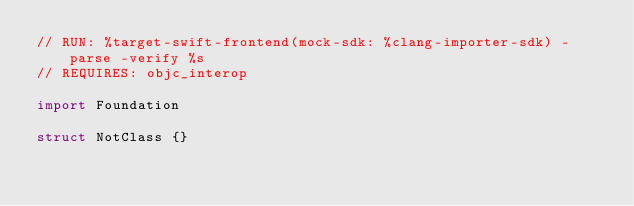<code> <loc_0><loc_0><loc_500><loc_500><_Swift_>// RUN: %target-swift-frontend(mock-sdk: %clang-importer-sdk) -parse -verify %s
// REQUIRES: objc_interop

import Foundation

struct NotClass {}
</code> 